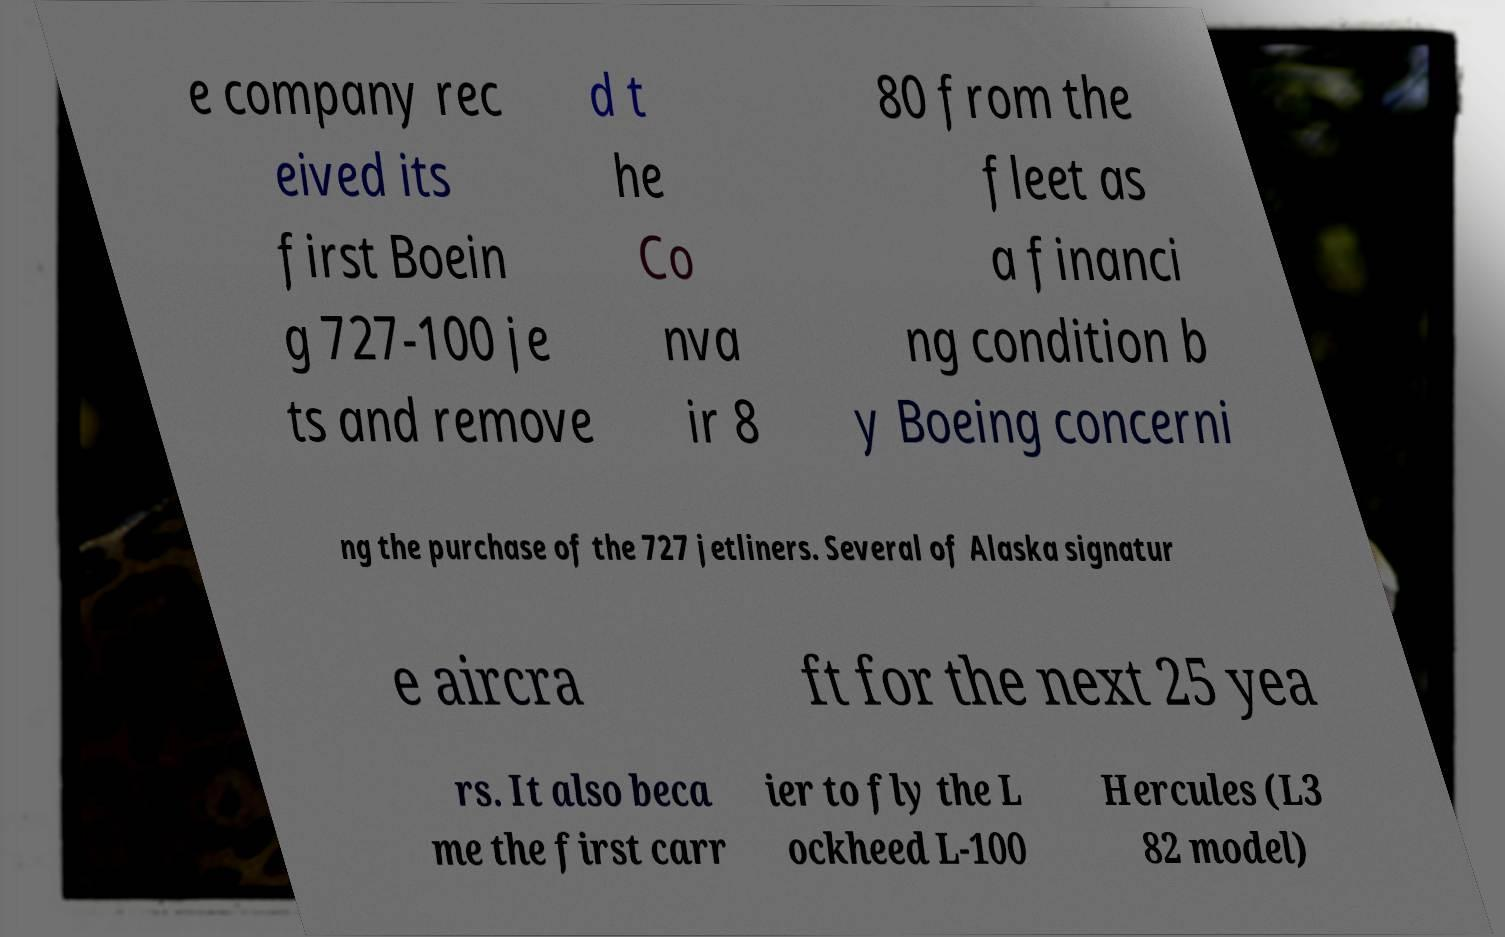Please read and relay the text visible in this image. What does it say? e company rec eived its first Boein g 727-100 je ts and remove d t he Co nva ir 8 80 from the fleet as a financi ng condition b y Boeing concerni ng the purchase of the 727 jetliners. Several of Alaska signatur e aircra ft for the next 25 yea rs. It also beca me the first carr ier to fly the L ockheed L-100 Hercules (L3 82 model) 